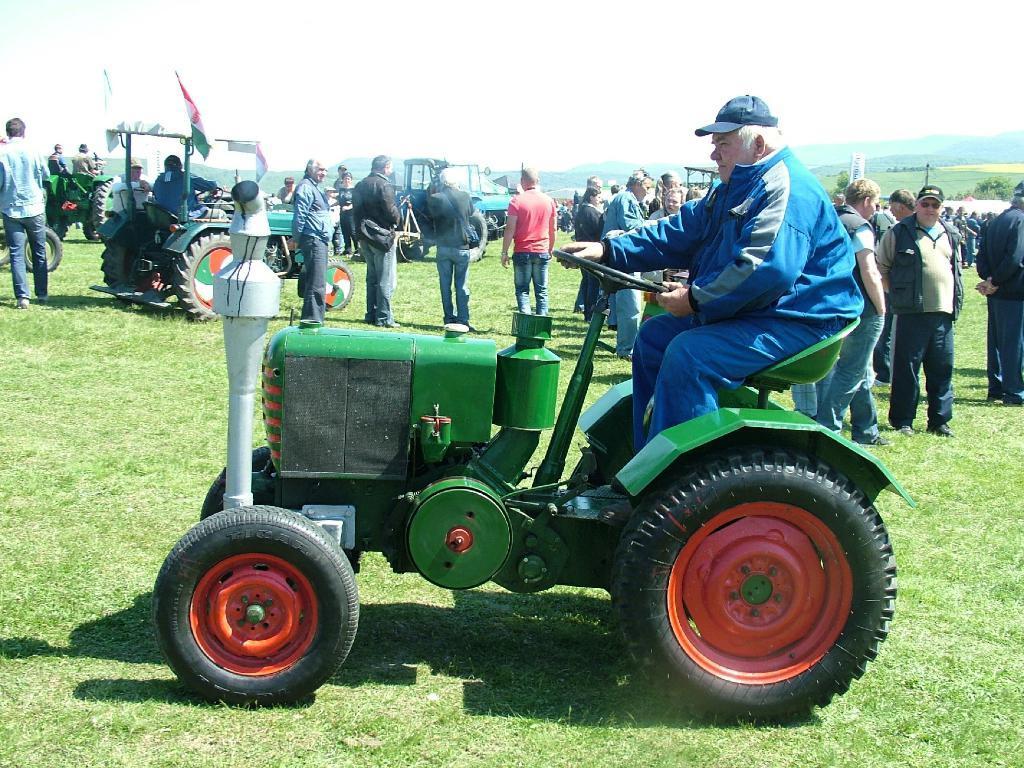Please provide a concise description of this image. In this image I can see there are so many persons standing on the ground and some persons riding on vehicles at the top I can see the sky. 